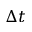<formula> <loc_0><loc_0><loc_500><loc_500>\Delta t</formula> 